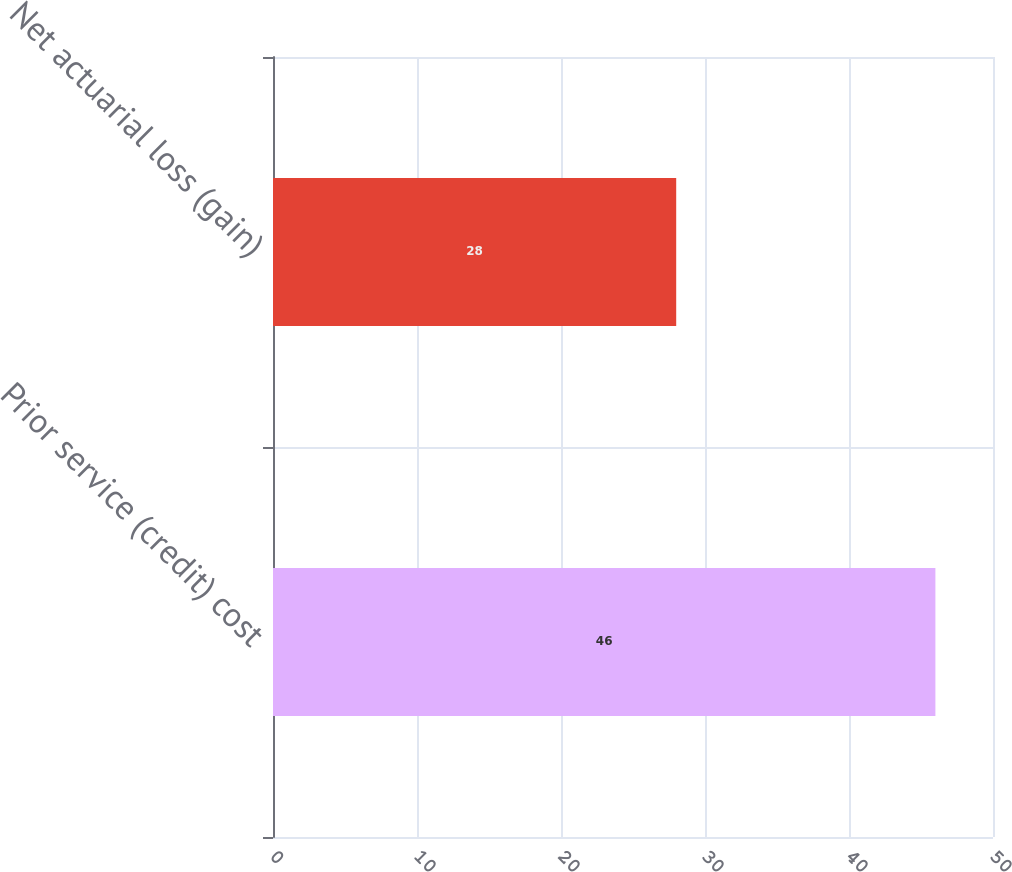<chart> <loc_0><loc_0><loc_500><loc_500><bar_chart><fcel>Prior service (credit) cost<fcel>Net actuarial loss (gain)<nl><fcel>46<fcel>28<nl></chart> 